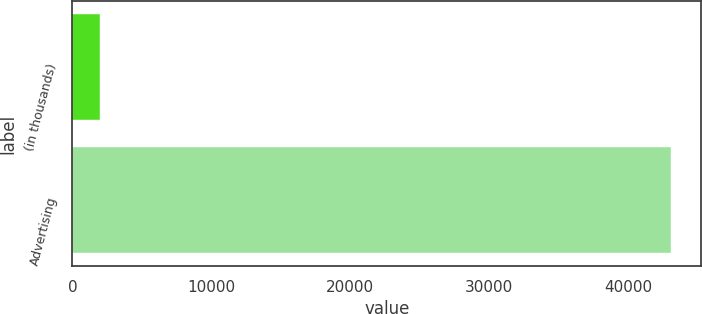<chart> <loc_0><loc_0><loc_500><loc_500><bar_chart><fcel>(in thousands)<fcel>Advertising<nl><fcel>2010<fcel>43119<nl></chart> 